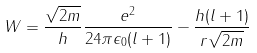<formula> <loc_0><loc_0><loc_500><loc_500>W = { \frac { \sqrt { 2 m } } { h } } { \frac { e ^ { 2 } } { 2 4 \pi \epsilon _ { 0 } ( l + 1 ) } } - { \frac { h ( l + 1 ) } { r { \sqrt { 2 m } } } }</formula> 